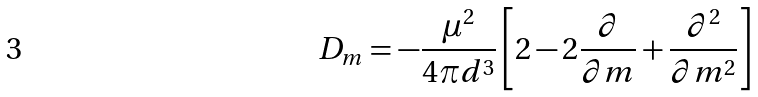<formula> <loc_0><loc_0><loc_500><loc_500>D _ { m } = - \frac { \mu ^ { 2 } } { 4 \pi d ^ { 3 } } \left [ 2 - 2 \frac { \partial } { \partial m } + \frac { \partial ^ { 2 } } { \partial m ^ { 2 } } \right ]</formula> 